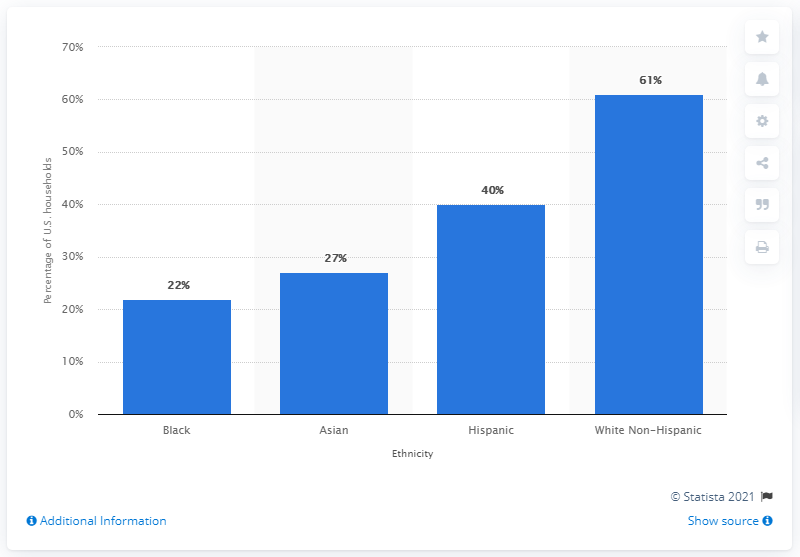Highlight a few significant elements in this photo. According to a study conducted in 2011, White Non-Hispanic individuals in the United States had the highest ownership rates of dogs and cats. In 2011, black and Asian races had the lowest ownership of pets in the United States, according to a survey. 